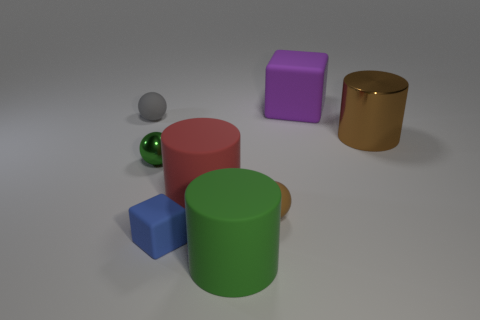Add 2 rubber cylinders. How many objects exist? 10 Subtract all spheres. How many objects are left? 5 Subtract all large blue matte balls. Subtract all rubber blocks. How many objects are left? 6 Add 7 large brown shiny objects. How many large brown shiny objects are left? 8 Add 1 large blue objects. How many large blue objects exist? 1 Subtract 0 yellow cylinders. How many objects are left? 8 